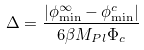<formula> <loc_0><loc_0><loc_500><loc_500>\Delta = \frac { | \phi _ { \min } ^ { \infty } - \phi _ { \min } ^ { c } | } { 6 \beta M _ { P l } \Phi _ { c } }</formula> 